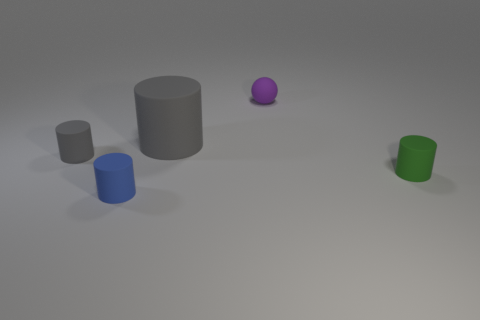What is the material of the cylinder that is the same color as the large matte object?
Offer a terse response. Rubber. What material is the gray cylinder that is the same size as the purple rubber thing?
Your answer should be very brief. Rubber. There is a small green object that is the same shape as the blue matte object; what is its material?
Offer a terse response. Rubber. How many tiny purple balls are there?
Provide a succinct answer. 1. There is a matte thing right of the purple sphere; what is its shape?
Provide a short and direct response. Cylinder. The object that is left of the rubber cylinder that is in front of the object to the right of the purple rubber thing is what color?
Your answer should be compact. Gray. What is the shape of the purple thing that is made of the same material as the blue cylinder?
Offer a very short reply. Sphere. Are there fewer tiny cyan shiny objects than blue rubber cylinders?
Your answer should be very brief. Yes. Are the tiny blue thing and the purple ball made of the same material?
Offer a terse response. Yes. What number of other objects are there of the same color as the large cylinder?
Offer a terse response. 1. 